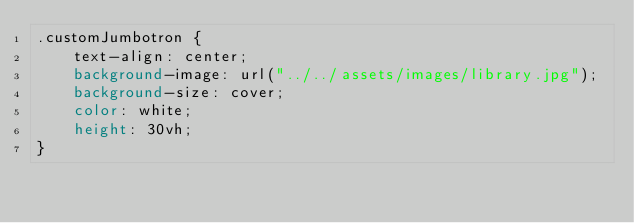Convert code to text. <code><loc_0><loc_0><loc_500><loc_500><_CSS_>.customJumbotron {
    text-align: center;
    background-image: url("../../assets/images/library.jpg");
    background-size: cover;
    color: white;
    height: 30vh;
}</code> 